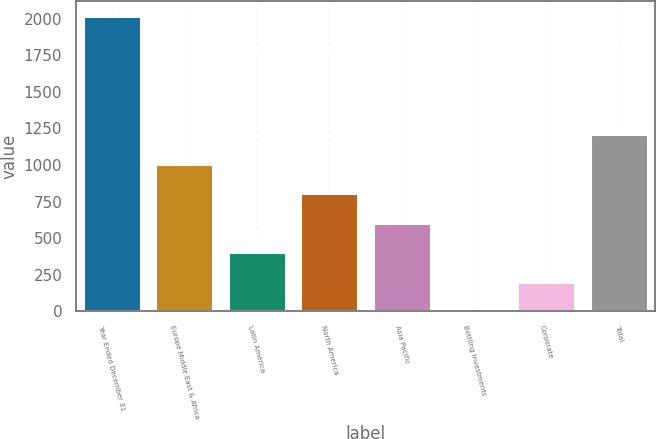Convert chart. <chart><loc_0><loc_0><loc_500><loc_500><bar_chart><fcel>Year Ended December 31<fcel>Europe Middle East & Africa<fcel>Latin America<fcel>North America<fcel>Asia Pacific<fcel>Bottling Investments<fcel>Corporate<fcel>Total<nl><fcel>2016<fcel>1008.8<fcel>404.48<fcel>807.36<fcel>605.92<fcel>1.6<fcel>203.04<fcel>1210.24<nl></chart> 